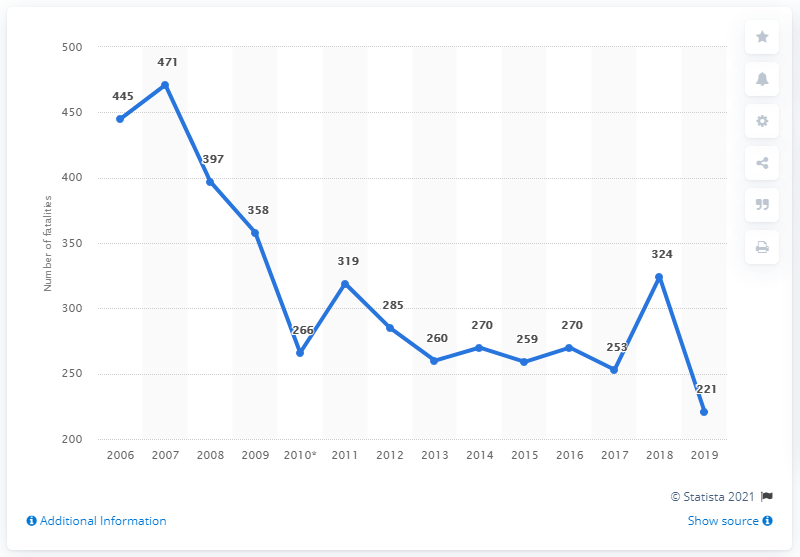Draw attention to some important aspects in this diagram. In 2019, the number of road fatalities in Sweden was 221, the lowest on record. 